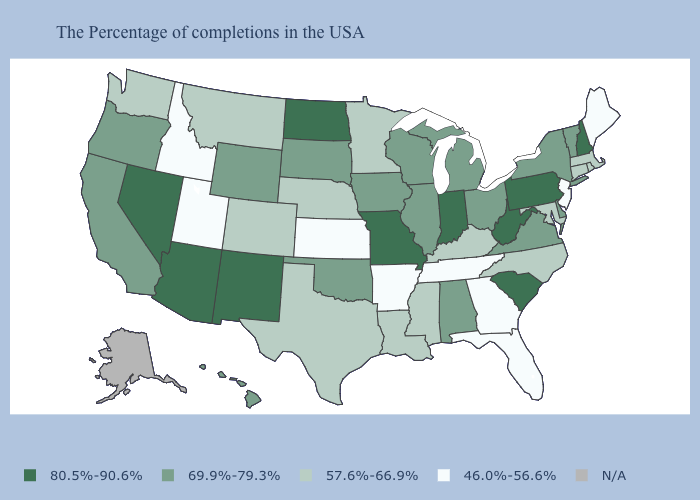Which states have the lowest value in the USA?
Give a very brief answer. Maine, New Jersey, Florida, Georgia, Tennessee, Arkansas, Kansas, Utah, Idaho. What is the highest value in states that border South Dakota?
Write a very short answer. 80.5%-90.6%. Which states have the lowest value in the USA?
Concise answer only. Maine, New Jersey, Florida, Georgia, Tennessee, Arkansas, Kansas, Utah, Idaho. Does West Virginia have the highest value in the USA?
Give a very brief answer. Yes. What is the value of Nevada?
Write a very short answer. 80.5%-90.6%. How many symbols are there in the legend?
Keep it brief. 5. What is the highest value in the MidWest ?
Keep it brief. 80.5%-90.6%. Name the states that have a value in the range 80.5%-90.6%?
Short answer required. New Hampshire, Pennsylvania, South Carolina, West Virginia, Indiana, Missouri, North Dakota, New Mexico, Arizona, Nevada. Does New Hampshire have the highest value in the Northeast?
Answer briefly. Yes. What is the highest value in the USA?
Answer briefly. 80.5%-90.6%. Does Wyoming have the highest value in the West?
Keep it brief. No. Name the states that have a value in the range 57.6%-66.9%?
Quick response, please. Massachusetts, Rhode Island, Connecticut, Maryland, North Carolina, Kentucky, Mississippi, Louisiana, Minnesota, Nebraska, Texas, Colorado, Montana, Washington. Does the first symbol in the legend represent the smallest category?
Be succinct. No. What is the value of North Carolina?
Answer briefly. 57.6%-66.9%. 